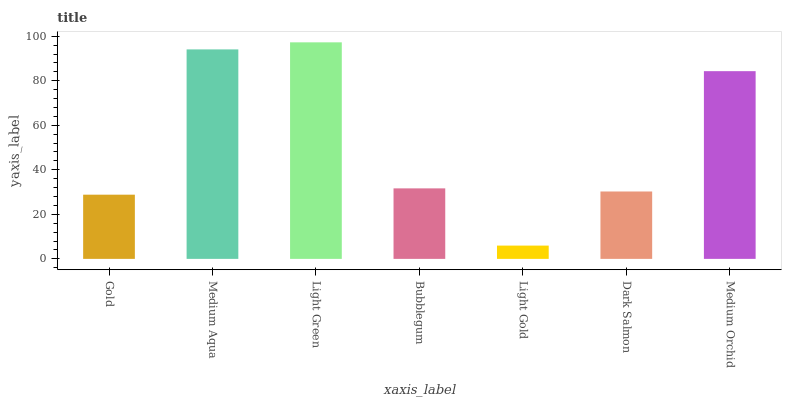Is Light Gold the minimum?
Answer yes or no. Yes. Is Light Green the maximum?
Answer yes or no. Yes. Is Medium Aqua the minimum?
Answer yes or no. No. Is Medium Aqua the maximum?
Answer yes or no. No. Is Medium Aqua greater than Gold?
Answer yes or no. Yes. Is Gold less than Medium Aqua?
Answer yes or no. Yes. Is Gold greater than Medium Aqua?
Answer yes or no. No. Is Medium Aqua less than Gold?
Answer yes or no. No. Is Bubblegum the high median?
Answer yes or no. Yes. Is Bubblegum the low median?
Answer yes or no. Yes. Is Gold the high median?
Answer yes or no. No. Is Light Green the low median?
Answer yes or no. No. 